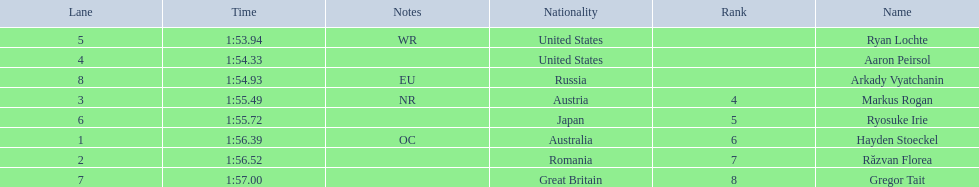How long did it take ryosuke irie to finish? 1:55.72. Write the full table. {'header': ['Lane', 'Time', 'Notes', 'Nationality', 'Rank', 'Name'], 'rows': [['5', '1:53.94', 'WR', 'United States', '', 'Ryan Lochte'], ['4', '1:54.33', '', 'United States', '', 'Aaron Peirsol'], ['8', '1:54.93', 'EU', 'Russia', '', 'Arkady Vyatchanin'], ['3', '1:55.49', 'NR', 'Austria', '4', 'Markus Rogan'], ['6', '1:55.72', '', 'Japan', '5', 'Ryosuke Irie'], ['1', '1:56.39', 'OC', 'Australia', '6', 'Hayden Stoeckel'], ['2', '1:56.52', '', 'Romania', '7', 'Răzvan Florea'], ['7', '1:57.00', '', 'Great Britain', '8', 'Gregor Tait']]} 